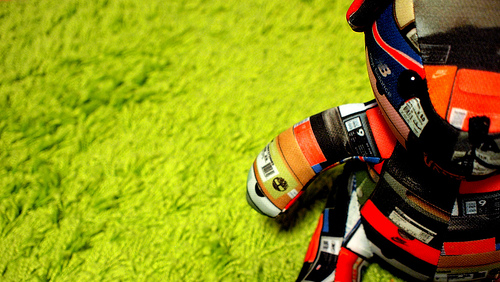<image>
Can you confirm if the stuffed animal is on the carpet? Yes. Looking at the image, I can see the stuffed animal is positioned on top of the carpet, with the carpet providing support. 